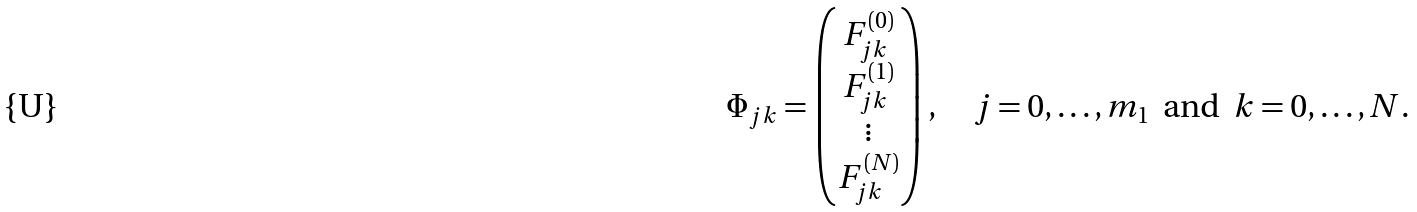<formula> <loc_0><loc_0><loc_500><loc_500>\Phi _ { j k } = \begin{pmatrix} F ^ { ( 0 ) } _ { j k } \\ F ^ { ( 1 ) } _ { j k } \\ \vdots \\ F ^ { ( N ) } _ { j k } \end{pmatrix} , \quad j = 0 , \dots , m _ { 1 } \text {\, and\, } k = 0 , \dots , N .</formula> 